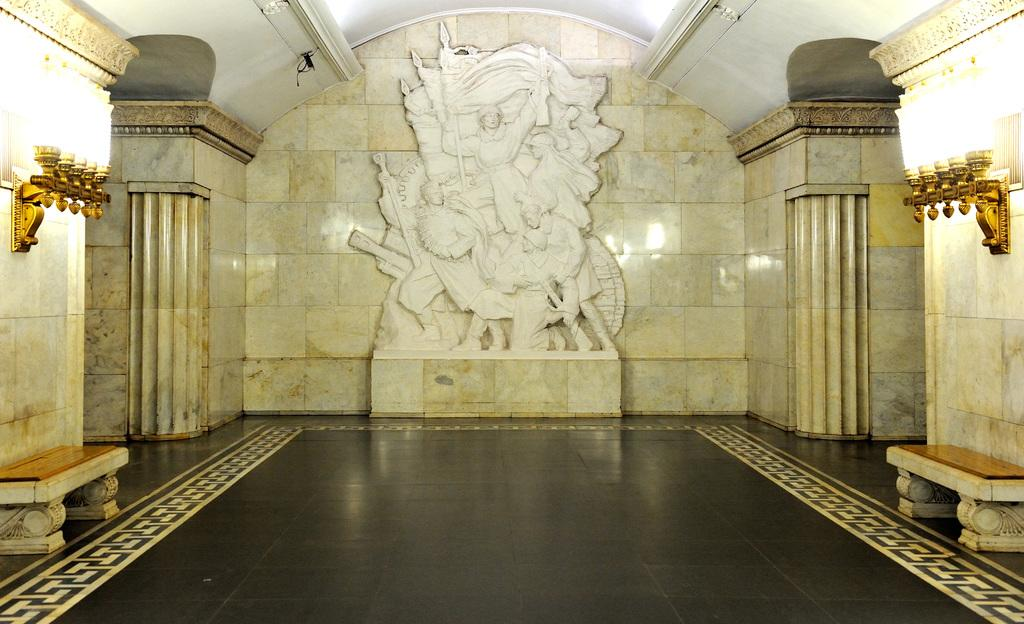What type of surface is visible in the image? There is a floor in the image. What type of furniture is present in the image? There are benches in the image. What type of architectural elements can be seen in the image? There are walls in the image. What type of illumination is present in the image? There are lights in the image. What type of artwork is present in the image? There is a sculpture in the image. Can you tell me how many people are controlling the sculpture in the image? There is no indication in the image that the sculpture is being controlled by anyone, nor are there any people present in the image. 